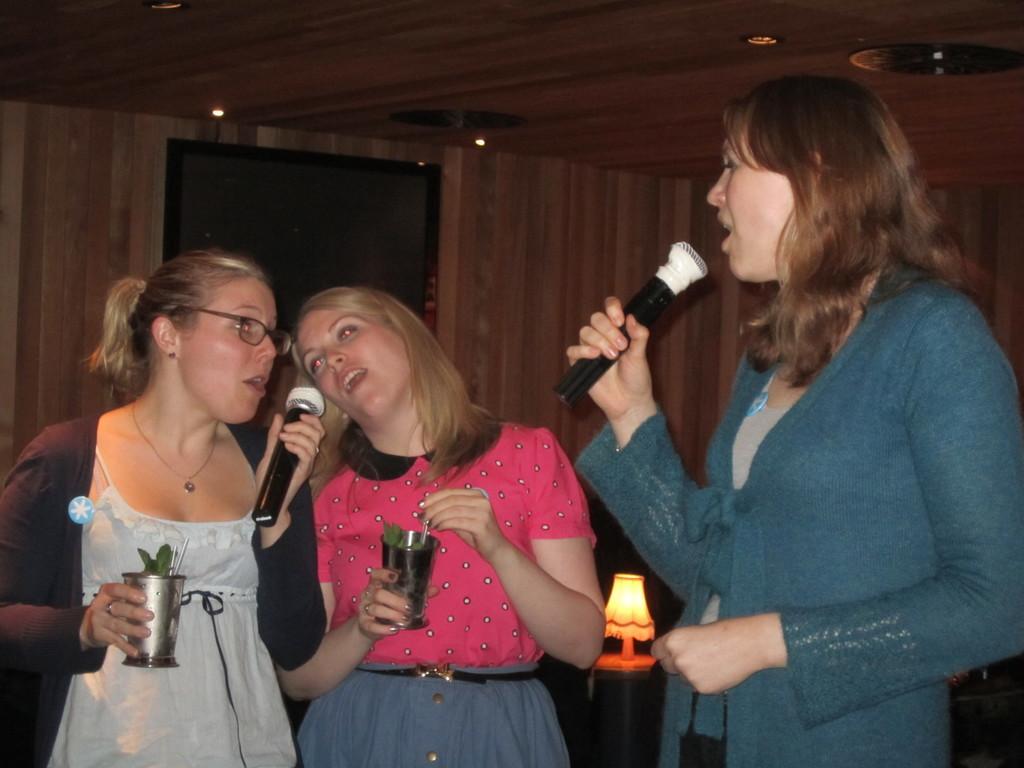How would you summarize this image in a sentence or two? There are three women standing and singing a song. Two of them are holding glass tumbler on their hands. At background I can see a lamp placed on the table. This looks like a door. 